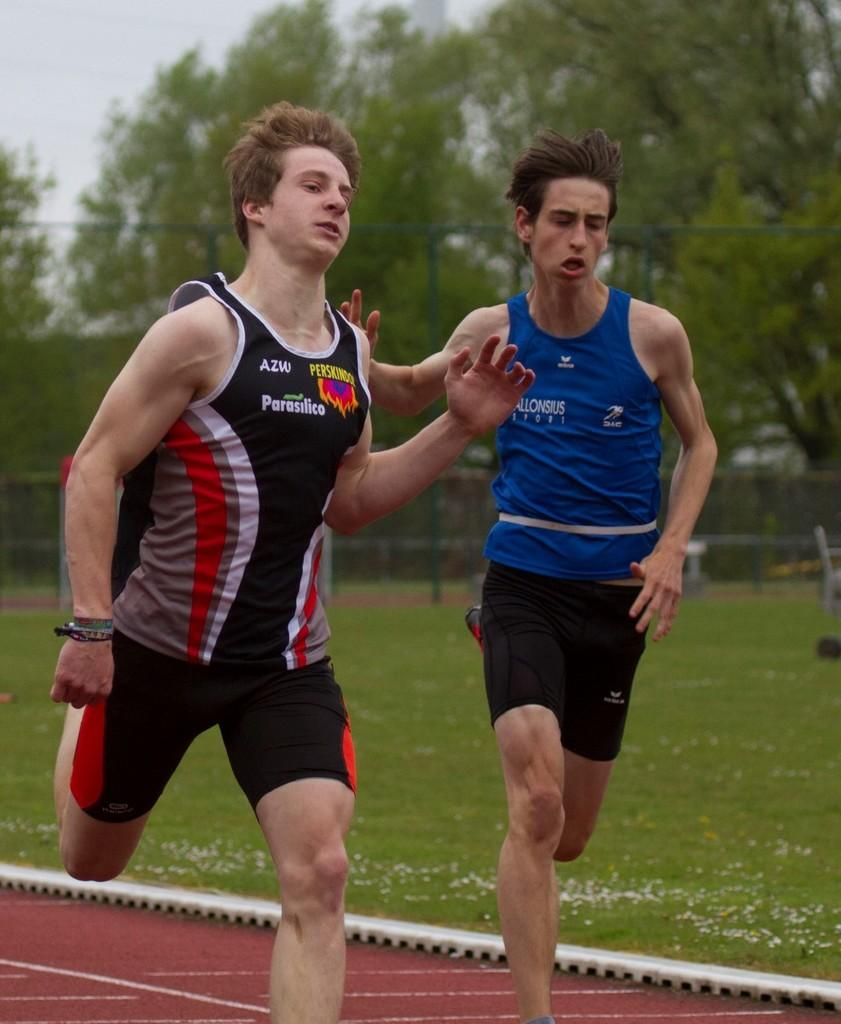How many people are in the image? There are two men in the image. What are the men doing in the image? The men are running. What type of clothing are the men wearing? The men are wearing T-shirts and shorts. What is the natural environment visible in the image? There is grass visible in the image, and there are trees in the background. What architectural feature can be seen in the background of the image? There is a fence in the background of the image. What color is the humor in the image? There is no humor present in the image, and therefore no color can be assigned to it. 